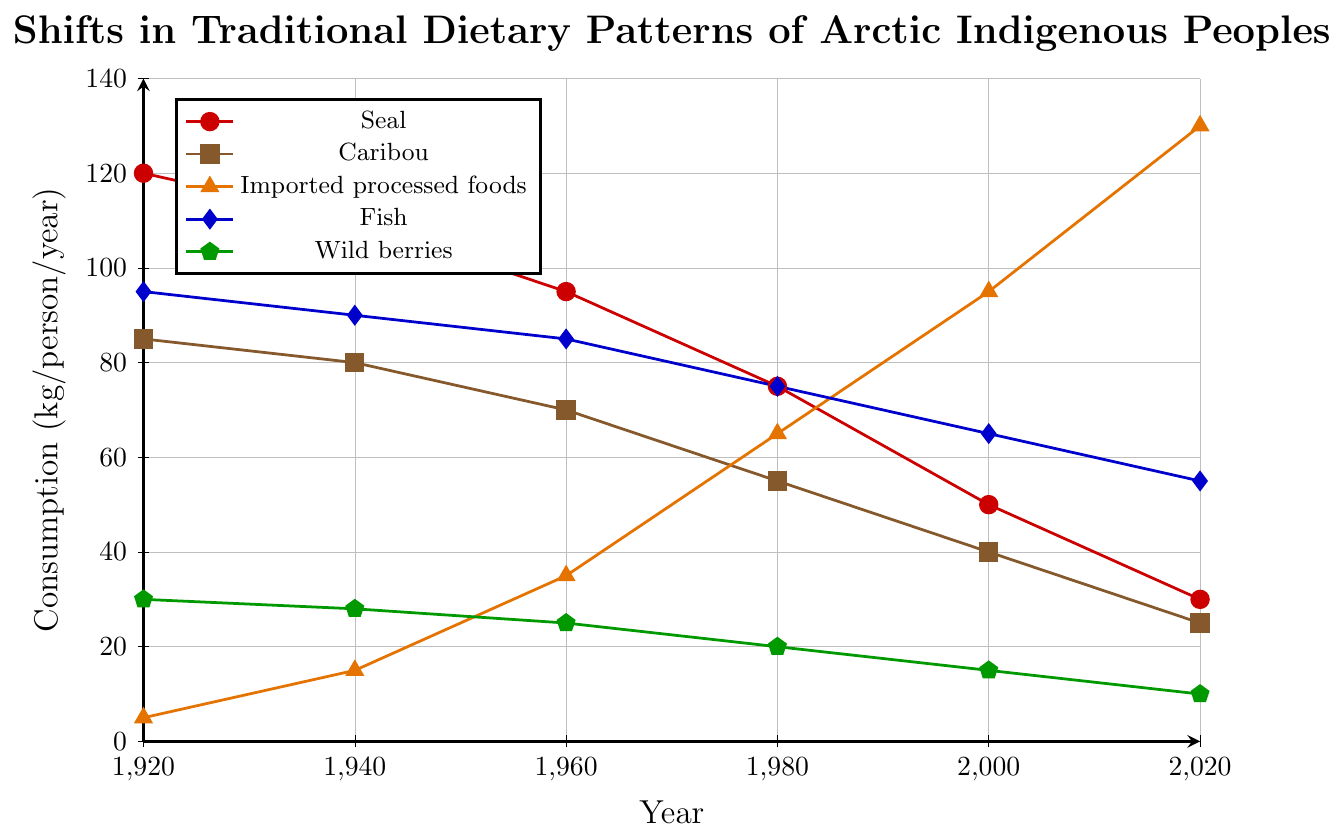What year had the highest consumption of seal meat? The highest point on the red line corresponds to the year 1920.
Answer: 1920 How much did the consumption of imported processed foods increase from 1920 to 2020? The value for imported processed foods in 1920 was 5 kg/person/year and increased to 130 kg/person/year by 2020. The increase is 130 - 5 = 125 kg/person/year.
Answer: 125 kg/person/year In what year did fish consumption start to drop below 80 kg/person/year? By examining the blue line, fish consumption drops below 80 kg/person/year after 1980.
Answer: 2000 How much more wild berries were consumed compared to imported processed foods in 1940? In 1940, 28 kg/person/year of wild berries and 15 kg/person/year of imported processed foods were consumed. The difference is 28 - 15 = 13 kg/person/year.
Answer: 13 kg/person/year Which food group's consumption remained the most stable from 1920 to 2020? The green line corresponding to wild berries shows the minimal change over time compared to other foods.
Answer: Wild berries Combine the total consumption of fish and caribou in 1960. Fish consumption in 1960 was 85 kg/person/year, and caribou consumption was 70 kg/person/year. Their total is 85 + 70 = 155 kg/person/year.
Answer: 155 kg/person/year Which year had the lowest combined consumption of seal and caribou meat? By analyzing the red and brown lines for each year, in 2020 the combined lowest consumption is 30 kg/person/year (seal) + 25 kg/person/year (caribou) = 55 kg/person/year.
Answer: 2020 Compare the decrease in seal consumption from 1920 to 1980 with the decrease in fish consumption over the same period. Which one is greater? Seal consumption decreased from 120 kg/person/year in 1920 to 75 kg/person/year in 1980, a decrease of 120 - 75 = 45 kg/person/year. Fish consumption decreased from 95 kg/person/year to 75 kg/person/year, a decrease of 95 - 75 = 20 kg/person/year. The decrease in seal consumption is greater.
Answer: Seal consumption What is the average consumption of wild berries over the entire timeline? The data points for wild berries are 30, 28, 25, 20, 15, and 10 kg/person/year. Their total sum is 128. The average is 128 / 6 = 21.33 kg/person/year.
Answer: 21.33 kg/person/year In what year did the consumption of imported processed foods surpass the consumption of fish? By observing the orange and blue lines, imported processed foods consumption surpasses fish between 1980 and 2000.
Answer: 2000 